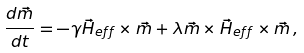Convert formula to latex. <formula><loc_0><loc_0><loc_500><loc_500>\frac { d \vec { m } } { d t } = - \gamma \vec { H } _ { e f f } \times \vec { m } + \lambda \vec { m } \times \vec { H } _ { e f f } \times \vec { m } \, ,</formula> 